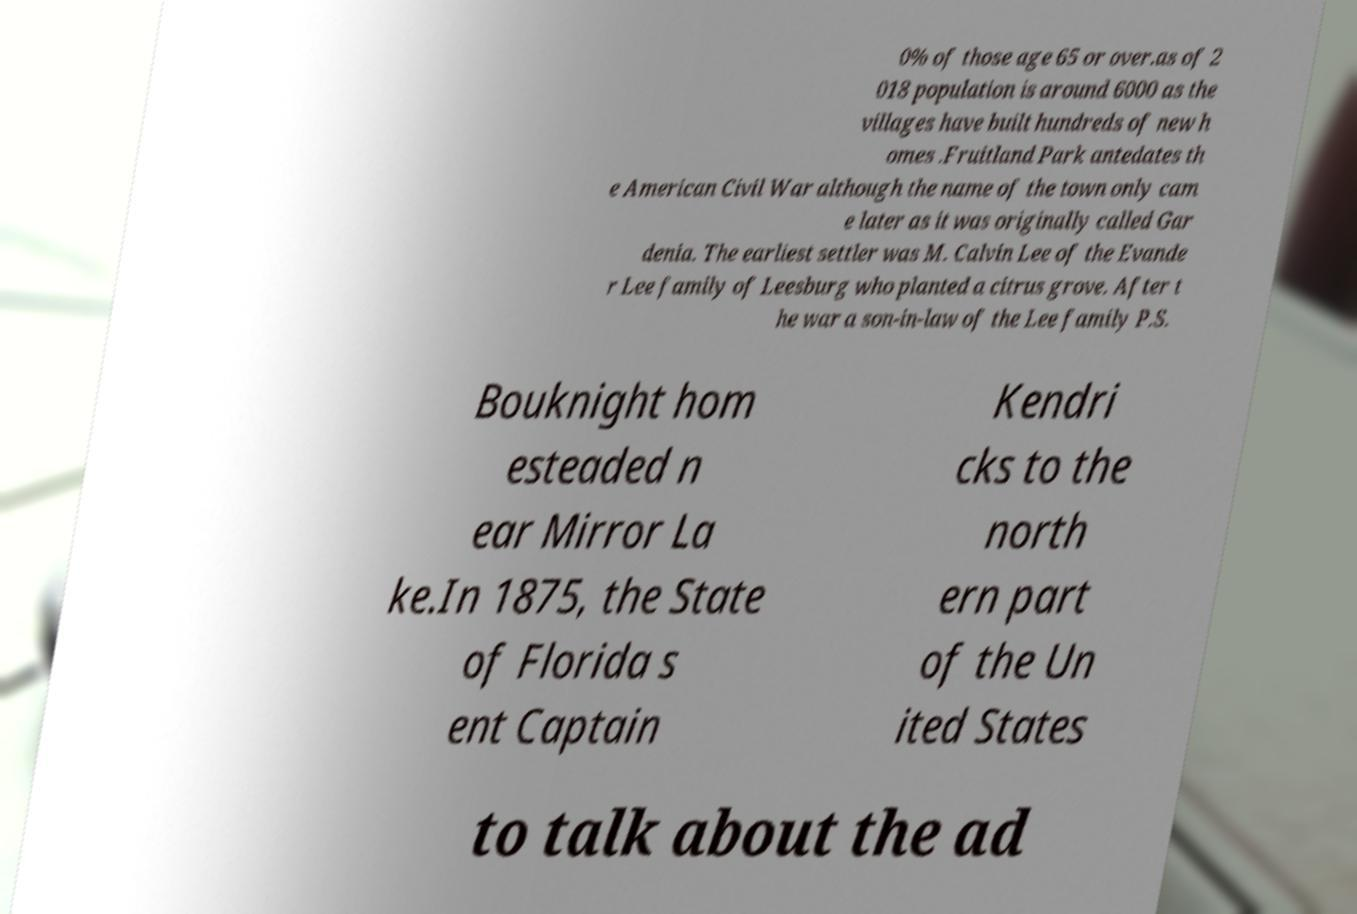Can you read and provide the text displayed in the image?This photo seems to have some interesting text. Can you extract and type it out for me? 0% of those age 65 or over.as of 2 018 population is around 6000 as the villages have built hundreds of new h omes .Fruitland Park antedates th e American Civil War although the name of the town only cam e later as it was originally called Gar denia. The earliest settler was M. Calvin Lee of the Evande r Lee family of Leesburg who planted a citrus grove. After t he war a son-in-law of the Lee family P.S. Bouknight hom esteaded n ear Mirror La ke.In 1875, the State of Florida s ent Captain Kendri cks to the north ern part of the Un ited States to talk about the ad 